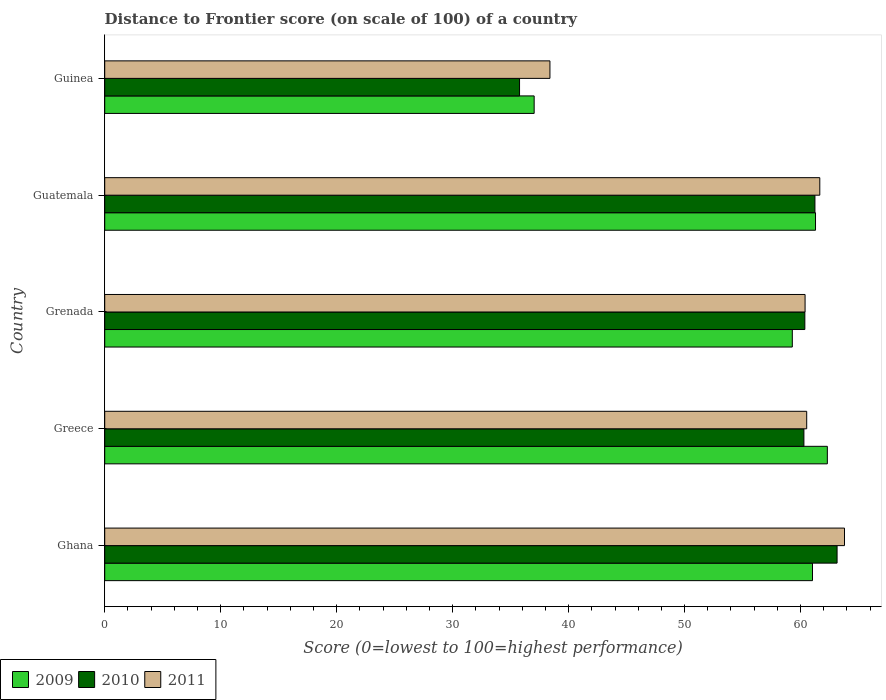How many different coloured bars are there?
Your answer should be very brief. 3. How many groups of bars are there?
Ensure brevity in your answer.  5. Are the number of bars per tick equal to the number of legend labels?
Offer a very short reply. Yes. How many bars are there on the 2nd tick from the top?
Make the answer very short. 3. How many bars are there on the 5th tick from the bottom?
Make the answer very short. 3. What is the label of the 2nd group of bars from the top?
Your answer should be very brief. Guatemala. What is the distance to frontier score of in 2009 in Guinea?
Keep it short and to the point. 37.03. Across all countries, what is the maximum distance to frontier score of in 2009?
Keep it short and to the point. 62.31. Across all countries, what is the minimum distance to frontier score of in 2009?
Keep it short and to the point. 37.03. In which country was the distance to frontier score of in 2009 minimum?
Keep it short and to the point. Guinea. What is the total distance to frontier score of in 2011 in the graph?
Provide a short and direct response. 284.76. What is the difference between the distance to frontier score of in 2011 in Guatemala and that in Guinea?
Ensure brevity in your answer.  23.27. What is the difference between the distance to frontier score of in 2010 in Greece and the distance to frontier score of in 2011 in Guinea?
Provide a succinct answer. 21.9. What is the average distance to frontier score of in 2011 per country?
Make the answer very short. 56.95. What is the difference between the distance to frontier score of in 2010 and distance to frontier score of in 2009 in Greece?
Offer a very short reply. -2.02. In how many countries, is the distance to frontier score of in 2009 greater than 24 ?
Provide a short and direct response. 5. What is the ratio of the distance to frontier score of in 2011 in Ghana to that in Grenada?
Your answer should be very brief. 1.06. Is the distance to frontier score of in 2009 in Ghana less than that in Grenada?
Give a very brief answer. No. Is the difference between the distance to frontier score of in 2010 in Grenada and Guatemala greater than the difference between the distance to frontier score of in 2009 in Grenada and Guatemala?
Offer a very short reply. Yes. What is the difference between the highest and the second highest distance to frontier score of in 2009?
Offer a very short reply. 1.02. What is the difference between the highest and the lowest distance to frontier score of in 2011?
Give a very brief answer. 25.4. In how many countries, is the distance to frontier score of in 2010 greater than the average distance to frontier score of in 2010 taken over all countries?
Provide a short and direct response. 4. What does the 2nd bar from the top in Guinea represents?
Offer a terse response. 2010. What does the 3rd bar from the bottom in Greece represents?
Offer a terse response. 2011. How many bars are there?
Give a very brief answer. 15. What is the difference between two consecutive major ticks on the X-axis?
Your answer should be compact. 10. Are the values on the major ticks of X-axis written in scientific E-notation?
Give a very brief answer. No. What is the title of the graph?
Provide a short and direct response. Distance to Frontier score (on scale of 100) of a country. Does "1980" appear as one of the legend labels in the graph?
Your response must be concise. No. What is the label or title of the X-axis?
Your response must be concise. Score (0=lowest to 100=highest performance). What is the label or title of the Y-axis?
Make the answer very short. Country. What is the Score (0=lowest to 100=highest performance) in 2009 in Ghana?
Make the answer very short. 61.03. What is the Score (0=lowest to 100=highest performance) of 2010 in Ghana?
Keep it short and to the point. 63.15. What is the Score (0=lowest to 100=highest performance) of 2011 in Ghana?
Make the answer very short. 63.79. What is the Score (0=lowest to 100=highest performance) of 2009 in Greece?
Your response must be concise. 62.31. What is the Score (0=lowest to 100=highest performance) in 2010 in Greece?
Make the answer very short. 60.29. What is the Score (0=lowest to 100=highest performance) of 2011 in Greece?
Keep it short and to the point. 60.53. What is the Score (0=lowest to 100=highest performance) in 2009 in Grenada?
Provide a succinct answer. 59.29. What is the Score (0=lowest to 100=highest performance) of 2010 in Grenada?
Offer a terse response. 60.37. What is the Score (0=lowest to 100=highest performance) of 2011 in Grenada?
Give a very brief answer. 60.39. What is the Score (0=lowest to 100=highest performance) in 2009 in Guatemala?
Make the answer very short. 61.29. What is the Score (0=lowest to 100=highest performance) of 2010 in Guatemala?
Ensure brevity in your answer.  61.24. What is the Score (0=lowest to 100=highest performance) in 2011 in Guatemala?
Your answer should be very brief. 61.66. What is the Score (0=lowest to 100=highest performance) of 2009 in Guinea?
Keep it short and to the point. 37.03. What is the Score (0=lowest to 100=highest performance) in 2010 in Guinea?
Your response must be concise. 35.77. What is the Score (0=lowest to 100=highest performance) of 2011 in Guinea?
Give a very brief answer. 38.39. Across all countries, what is the maximum Score (0=lowest to 100=highest performance) of 2009?
Offer a terse response. 62.31. Across all countries, what is the maximum Score (0=lowest to 100=highest performance) of 2010?
Provide a succinct answer. 63.15. Across all countries, what is the maximum Score (0=lowest to 100=highest performance) in 2011?
Offer a very short reply. 63.79. Across all countries, what is the minimum Score (0=lowest to 100=highest performance) in 2009?
Provide a short and direct response. 37.03. Across all countries, what is the minimum Score (0=lowest to 100=highest performance) of 2010?
Give a very brief answer. 35.77. Across all countries, what is the minimum Score (0=lowest to 100=highest performance) of 2011?
Ensure brevity in your answer.  38.39. What is the total Score (0=lowest to 100=highest performance) in 2009 in the graph?
Provide a succinct answer. 280.95. What is the total Score (0=lowest to 100=highest performance) in 2010 in the graph?
Your answer should be very brief. 280.82. What is the total Score (0=lowest to 100=highest performance) in 2011 in the graph?
Offer a very short reply. 284.76. What is the difference between the Score (0=lowest to 100=highest performance) in 2009 in Ghana and that in Greece?
Give a very brief answer. -1.28. What is the difference between the Score (0=lowest to 100=highest performance) of 2010 in Ghana and that in Greece?
Your answer should be compact. 2.86. What is the difference between the Score (0=lowest to 100=highest performance) in 2011 in Ghana and that in Greece?
Your answer should be very brief. 3.26. What is the difference between the Score (0=lowest to 100=highest performance) of 2009 in Ghana and that in Grenada?
Your answer should be very brief. 1.74. What is the difference between the Score (0=lowest to 100=highest performance) in 2010 in Ghana and that in Grenada?
Your answer should be compact. 2.78. What is the difference between the Score (0=lowest to 100=highest performance) of 2009 in Ghana and that in Guatemala?
Your answer should be compact. -0.26. What is the difference between the Score (0=lowest to 100=highest performance) of 2010 in Ghana and that in Guatemala?
Keep it short and to the point. 1.91. What is the difference between the Score (0=lowest to 100=highest performance) in 2011 in Ghana and that in Guatemala?
Offer a very short reply. 2.13. What is the difference between the Score (0=lowest to 100=highest performance) of 2010 in Ghana and that in Guinea?
Make the answer very short. 27.38. What is the difference between the Score (0=lowest to 100=highest performance) in 2011 in Ghana and that in Guinea?
Keep it short and to the point. 25.4. What is the difference between the Score (0=lowest to 100=highest performance) of 2009 in Greece and that in Grenada?
Offer a very short reply. 3.02. What is the difference between the Score (0=lowest to 100=highest performance) of 2010 in Greece and that in Grenada?
Keep it short and to the point. -0.08. What is the difference between the Score (0=lowest to 100=highest performance) in 2011 in Greece and that in Grenada?
Your answer should be very brief. 0.14. What is the difference between the Score (0=lowest to 100=highest performance) in 2010 in Greece and that in Guatemala?
Make the answer very short. -0.95. What is the difference between the Score (0=lowest to 100=highest performance) in 2011 in Greece and that in Guatemala?
Ensure brevity in your answer.  -1.13. What is the difference between the Score (0=lowest to 100=highest performance) in 2009 in Greece and that in Guinea?
Offer a terse response. 25.28. What is the difference between the Score (0=lowest to 100=highest performance) in 2010 in Greece and that in Guinea?
Offer a very short reply. 24.52. What is the difference between the Score (0=lowest to 100=highest performance) of 2011 in Greece and that in Guinea?
Offer a terse response. 22.14. What is the difference between the Score (0=lowest to 100=highest performance) of 2010 in Grenada and that in Guatemala?
Your answer should be very brief. -0.87. What is the difference between the Score (0=lowest to 100=highest performance) of 2011 in Grenada and that in Guatemala?
Keep it short and to the point. -1.27. What is the difference between the Score (0=lowest to 100=highest performance) in 2009 in Grenada and that in Guinea?
Make the answer very short. 22.26. What is the difference between the Score (0=lowest to 100=highest performance) of 2010 in Grenada and that in Guinea?
Offer a very short reply. 24.6. What is the difference between the Score (0=lowest to 100=highest performance) of 2009 in Guatemala and that in Guinea?
Provide a short and direct response. 24.26. What is the difference between the Score (0=lowest to 100=highest performance) of 2010 in Guatemala and that in Guinea?
Your answer should be compact. 25.47. What is the difference between the Score (0=lowest to 100=highest performance) of 2011 in Guatemala and that in Guinea?
Keep it short and to the point. 23.27. What is the difference between the Score (0=lowest to 100=highest performance) of 2009 in Ghana and the Score (0=lowest to 100=highest performance) of 2010 in Greece?
Your answer should be compact. 0.74. What is the difference between the Score (0=lowest to 100=highest performance) in 2009 in Ghana and the Score (0=lowest to 100=highest performance) in 2011 in Greece?
Offer a terse response. 0.5. What is the difference between the Score (0=lowest to 100=highest performance) in 2010 in Ghana and the Score (0=lowest to 100=highest performance) in 2011 in Greece?
Keep it short and to the point. 2.62. What is the difference between the Score (0=lowest to 100=highest performance) of 2009 in Ghana and the Score (0=lowest to 100=highest performance) of 2010 in Grenada?
Make the answer very short. 0.66. What is the difference between the Score (0=lowest to 100=highest performance) of 2009 in Ghana and the Score (0=lowest to 100=highest performance) of 2011 in Grenada?
Give a very brief answer. 0.64. What is the difference between the Score (0=lowest to 100=highest performance) in 2010 in Ghana and the Score (0=lowest to 100=highest performance) in 2011 in Grenada?
Provide a short and direct response. 2.76. What is the difference between the Score (0=lowest to 100=highest performance) in 2009 in Ghana and the Score (0=lowest to 100=highest performance) in 2010 in Guatemala?
Offer a very short reply. -0.21. What is the difference between the Score (0=lowest to 100=highest performance) in 2009 in Ghana and the Score (0=lowest to 100=highest performance) in 2011 in Guatemala?
Ensure brevity in your answer.  -0.63. What is the difference between the Score (0=lowest to 100=highest performance) of 2010 in Ghana and the Score (0=lowest to 100=highest performance) of 2011 in Guatemala?
Your answer should be compact. 1.49. What is the difference between the Score (0=lowest to 100=highest performance) in 2009 in Ghana and the Score (0=lowest to 100=highest performance) in 2010 in Guinea?
Provide a succinct answer. 25.26. What is the difference between the Score (0=lowest to 100=highest performance) of 2009 in Ghana and the Score (0=lowest to 100=highest performance) of 2011 in Guinea?
Make the answer very short. 22.64. What is the difference between the Score (0=lowest to 100=highest performance) in 2010 in Ghana and the Score (0=lowest to 100=highest performance) in 2011 in Guinea?
Offer a terse response. 24.76. What is the difference between the Score (0=lowest to 100=highest performance) of 2009 in Greece and the Score (0=lowest to 100=highest performance) of 2010 in Grenada?
Your answer should be very brief. 1.94. What is the difference between the Score (0=lowest to 100=highest performance) in 2009 in Greece and the Score (0=lowest to 100=highest performance) in 2011 in Grenada?
Ensure brevity in your answer.  1.92. What is the difference between the Score (0=lowest to 100=highest performance) of 2009 in Greece and the Score (0=lowest to 100=highest performance) of 2010 in Guatemala?
Give a very brief answer. 1.07. What is the difference between the Score (0=lowest to 100=highest performance) in 2009 in Greece and the Score (0=lowest to 100=highest performance) in 2011 in Guatemala?
Make the answer very short. 0.65. What is the difference between the Score (0=lowest to 100=highest performance) of 2010 in Greece and the Score (0=lowest to 100=highest performance) of 2011 in Guatemala?
Offer a terse response. -1.37. What is the difference between the Score (0=lowest to 100=highest performance) of 2009 in Greece and the Score (0=lowest to 100=highest performance) of 2010 in Guinea?
Provide a short and direct response. 26.54. What is the difference between the Score (0=lowest to 100=highest performance) in 2009 in Greece and the Score (0=lowest to 100=highest performance) in 2011 in Guinea?
Provide a succinct answer. 23.92. What is the difference between the Score (0=lowest to 100=highest performance) of 2010 in Greece and the Score (0=lowest to 100=highest performance) of 2011 in Guinea?
Provide a short and direct response. 21.9. What is the difference between the Score (0=lowest to 100=highest performance) of 2009 in Grenada and the Score (0=lowest to 100=highest performance) of 2010 in Guatemala?
Make the answer very short. -1.95. What is the difference between the Score (0=lowest to 100=highest performance) in 2009 in Grenada and the Score (0=lowest to 100=highest performance) in 2011 in Guatemala?
Give a very brief answer. -2.37. What is the difference between the Score (0=lowest to 100=highest performance) of 2010 in Grenada and the Score (0=lowest to 100=highest performance) of 2011 in Guatemala?
Your answer should be very brief. -1.29. What is the difference between the Score (0=lowest to 100=highest performance) of 2009 in Grenada and the Score (0=lowest to 100=highest performance) of 2010 in Guinea?
Offer a very short reply. 23.52. What is the difference between the Score (0=lowest to 100=highest performance) in 2009 in Grenada and the Score (0=lowest to 100=highest performance) in 2011 in Guinea?
Ensure brevity in your answer.  20.9. What is the difference between the Score (0=lowest to 100=highest performance) of 2010 in Grenada and the Score (0=lowest to 100=highest performance) of 2011 in Guinea?
Make the answer very short. 21.98. What is the difference between the Score (0=lowest to 100=highest performance) of 2009 in Guatemala and the Score (0=lowest to 100=highest performance) of 2010 in Guinea?
Make the answer very short. 25.52. What is the difference between the Score (0=lowest to 100=highest performance) in 2009 in Guatemala and the Score (0=lowest to 100=highest performance) in 2011 in Guinea?
Make the answer very short. 22.9. What is the difference between the Score (0=lowest to 100=highest performance) of 2010 in Guatemala and the Score (0=lowest to 100=highest performance) of 2011 in Guinea?
Your answer should be very brief. 22.85. What is the average Score (0=lowest to 100=highest performance) in 2009 per country?
Offer a very short reply. 56.19. What is the average Score (0=lowest to 100=highest performance) in 2010 per country?
Your answer should be compact. 56.16. What is the average Score (0=lowest to 100=highest performance) of 2011 per country?
Your answer should be very brief. 56.95. What is the difference between the Score (0=lowest to 100=highest performance) in 2009 and Score (0=lowest to 100=highest performance) in 2010 in Ghana?
Provide a succinct answer. -2.12. What is the difference between the Score (0=lowest to 100=highest performance) of 2009 and Score (0=lowest to 100=highest performance) of 2011 in Ghana?
Offer a very short reply. -2.76. What is the difference between the Score (0=lowest to 100=highest performance) of 2010 and Score (0=lowest to 100=highest performance) of 2011 in Ghana?
Your response must be concise. -0.64. What is the difference between the Score (0=lowest to 100=highest performance) in 2009 and Score (0=lowest to 100=highest performance) in 2010 in Greece?
Keep it short and to the point. 2.02. What is the difference between the Score (0=lowest to 100=highest performance) of 2009 and Score (0=lowest to 100=highest performance) of 2011 in Greece?
Your answer should be compact. 1.78. What is the difference between the Score (0=lowest to 100=highest performance) in 2010 and Score (0=lowest to 100=highest performance) in 2011 in Greece?
Make the answer very short. -0.24. What is the difference between the Score (0=lowest to 100=highest performance) of 2009 and Score (0=lowest to 100=highest performance) of 2010 in Grenada?
Provide a succinct answer. -1.08. What is the difference between the Score (0=lowest to 100=highest performance) in 2010 and Score (0=lowest to 100=highest performance) in 2011 in Grenada?
Your answer should be very brief. -0.02. What is the difference between the Score (0=lowest to 100=highest performance) of 2009 and Score (0=lowest to 100=highest performance) of 2010 in Guatemala?
Give a very brief answer. 0.05. What is the difference between the Score (0=lowest to 100=highest performance) in 2009 and Score (0=lowest to 100=highest performance) in 2011 in Guatemala?
Make the answer very short. -0.37. What is the difference between the Score (0=lowest to 100=highest performance) of 2010 and Score (0=lowest to 100=highest performance) of 2011 in Guatemala?
Keep it short and to the point. -0.42. What is the difference between the Score (0=lowest to 100=highest performance) of 2009 and Score (0=lowest to 100=highest performance) of 2010 in Guinea?
Your answer should be very brief. 1.26. What is the difference between the Score (0=lowest to 100=highest performance) of 2009 and Score (0=lowest to 100=highest performance) of 2011 in Guinea?
Offer a very short reply. -1.36. What is the difference between the Score (0=lowest to 100=highest performance) of 2010 and Score (0=lowest to 100=highest performance) of 2011 in Guinea?
Provide a succinct answer. -2.62. What is the ratio of the Score (0=lowest to 100=highest performance) of 2009 in Ghana to that in Greece?
Offer a terse response. 0.98. What is the ratio of the Score (0=lowest to 100=highest performance) in 2010 in Ghana to that in Greece?
Your response must be concise. 1.05. What is the ratio of the Score (0=lowest to 100=highest performance) in 2011 in Ghana to that in Greece?
Offer a terse response. 1.05. What is the ratio of the Score (0=lowest to 100=highest performance) of 2009 in Ghana to that in Grenada?
Offer a terse response. 1.03. What is the ratio of the Score (0=lowest to 100=highest performance) in 2010 in Ghana to that in Grenada?
Ensure brevity in your answer.  1.05. What is the ratio of the Score (0=lowest to 100=highest performance) of 2011 in Ghana to that in Grenada?
Provide a short and direct response. 1.06. What is the ratio of the Score (0=lowest to 100=highest performance) in 2010 in Ghana to that in Guatemala?
Ensure brevity in your answer.  1.03. What is the ratio of the Score (0=lowest to 100=highest performance) of 2011 in Ghana to that in Guatemala?
Offer a terse response. 1.03. What is the ratio of the Score (0=lowest to 100=highest performance) in 2009 in Ghana to that in Guinea?
Give a very brief answer. 1.65. What is the ratio of the Score (0=lowest to 100=highest performance) of 2010 in Ghana to that in Guinea?
Ensure brevity in your answer.  1.77. What is the ratio of the Score (0=lowest to 100=highest performance) of 2011 in Ghana to that in Guinea?
Keep it short and to the point. 1.66. What is the ratio of the Score (0=lowest to 100=highest performance) of 2009 in Greece to that in Grenada?
Offer a very short reply. 1.05. What is the ratio of the Score (0=lowest to 100=highest performance) of 2009 in Greece to that in Guatemala?
Give a very brief answer. 1.02. What is the ratio of the Score (0=lowest to 100=highest performance) of 2010 in Greece to that in Guatemala?
Your answer should be compact. 0.98. What is the ratio of the Score (0=lowest to 100=highest performance) of 2011 in Greece to that in Guatemala?
Provide a short and direct response. 0.98. What is the ratio of the Score (0=lowest to 100=highest performance) of 2009 in Greece to that in Guinea?
Make the answer very short. 1.68. What is the ratio of the Score (0=lowest to 100=highest performance) in 2010 in Greece to that in Guinea?
Offer a very short reply. 1.69. What is the ratio of the Score (0=lowest to 100=highest performance) of 2011 in Greece to that in Guinea?
Your answer should be compact. 1.58. What is the ratio of the Score (0=lowest to 100=highest performance) in 2009 in Grenada to that in Guatemala?
Keep it short and to the point. 0.97. What is the ratio of the Score (0=lowest to 100=highest performance) of 2010 in Grenada to that in Guatemala?
Give a very brief answer. 0.99. What is the ratio of the Score (0=lowest to 100=highest performance) of 2011 in Grenada to that in Guatemala?
Your answer should be compact. 0.98. What is the ratio of the Score (0=lowest to 100=highest performance) of 2009 in Grenada to that in Guinea?
Make the answer very short. 1.6. What is the ratio of the Score (0=lowest to 100=highest performance) in 2010 in Grenada to that in Guinea?
Offer a terse response. 1.69. What is the ratio of the Score (0=lowest to 100=highest performance) in 2011 in Grenada to that in Guinea?
Your answer should be compact. 1.57. What is the ratio of the Score (0=lowest to 100=highest performance) in 2009 in Guatemala to that in Guinea?
Provide a succinct answer. 1.66. What is the ratio of the Score (0=lowest to 100=highest performance) of 2010 in Guatemala to that in Guinea?
Your response must be concise. 1.71. What is the ratio of the Score (0=lowest to 100=highest performance) in 2011 in Guatemala to that in Guinea?
Your response must be concise. 1.61. What is the difference between the highest and the second highest Score (0=lowest to 100=highest performance) in 2010?
Provide a short and direct response. 1.91. What is the difference between the highest and the second highest Score (0=lowest to 100=highest performance) of 2011?
Your answer should be very brief. 2.13. What is the difference between the highest and the lowest Score (0=lowest to 100=highest performance) of 2009?
Your response must be concise. 25.28. What is the difference between the highest and the lowest Score (0=lowest to 100=highest performance) of 2010?
Keep it short and to the point. 27.38. What is the difference between the highest and the lowest Score (0=lowest to 100=highest performance) in 2011?
Keep it short and to the point. 25.4. 